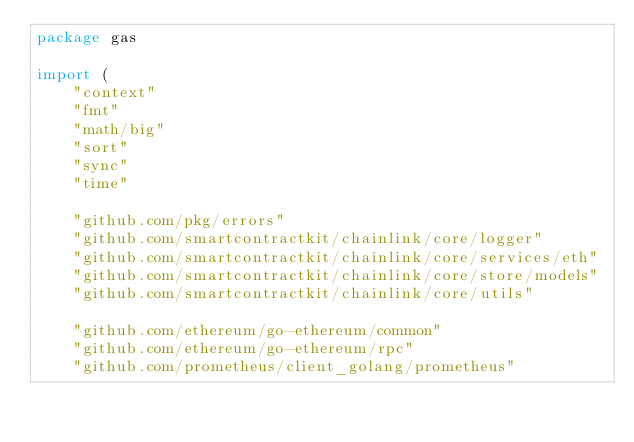<code> <loc_0><loc_0><loc_500><loc_500><_Go_>package gas

import (
	"context"
	"fmt"
	"math/big"
	"sort"
	"sync"
	"time"

	"github.com/pkg/errors"
	"github.com/smartcontractkit/chainlink/core/logger"
	"github.com/smartcontractkit/chainlink/core/services/eth"
	"github.com/smartcontractkit/chainlink/core/store/models"
	"github.com/smartcontractkit/chainlink/core/utils"

	"github.com/ethereum/go-ethereum/common"
	"github.com/ethereum/go-ethereum/rpc"
	"github.com/prometheus/client_golang/prometheus"</code> 